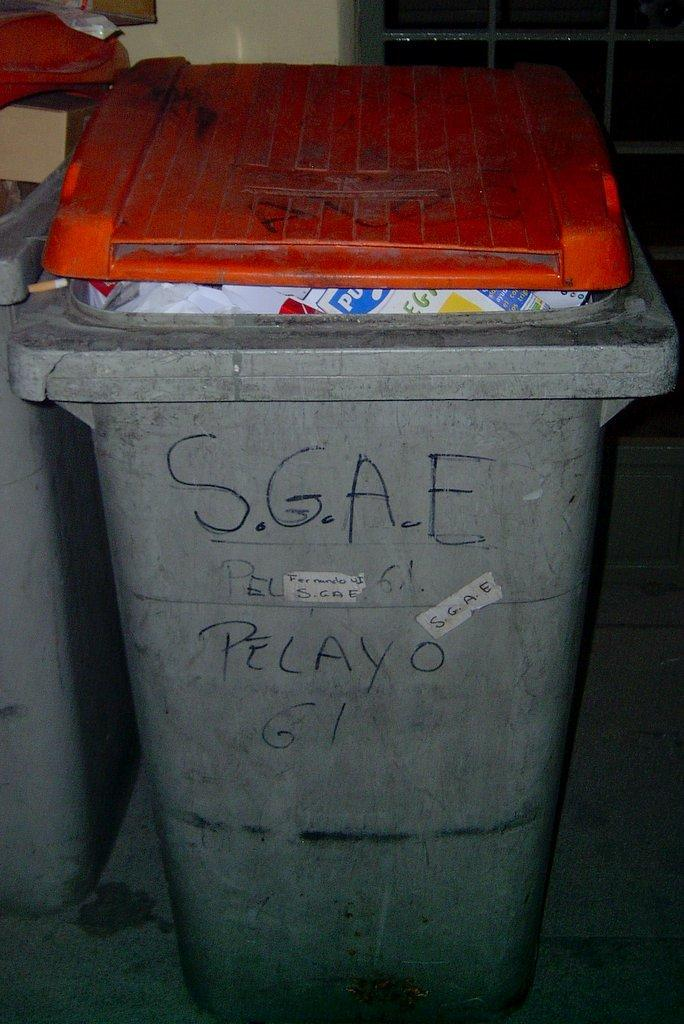<image>
Relay a brief, clear account of the picture shown. Gray garbgae can that says "Pelayo" on the front. 